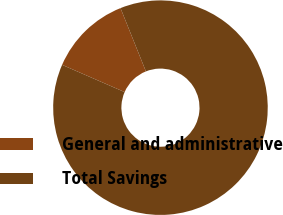Convert chart. <chart><loc_0><loc_0><loc_500><loc_500><pie_chart><fcel>General and administrative<fcel>Total Savings<nl><fcel>12.39%<fcel>87.61%<nl></chart> 